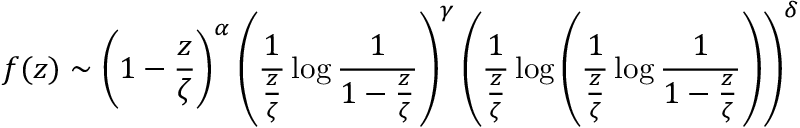<formula> <loc_0><loc_0><loc_500><loc_500>f ( z ) \sim \left ( 1 - { \frac { z } { \zeta } } \right ) ^ { \alpha } \left ( { \frac { 1 } { \frac { z } { \zeta } } } \log { \frac { 1 } { 1 - { \frac { z } { \zeta } } } } \right ) ^ { \gamma } \left ( { \frac { 1 } { \frac { z } { \zeta } } } \log \left ( { \frac { 1 } { \frac { z } { \zeta } } } \log { \frac { 1 } { 1 - { \frac { z } { \zeta } } } } \right ) \right ) ^ { \delta }</formula> 